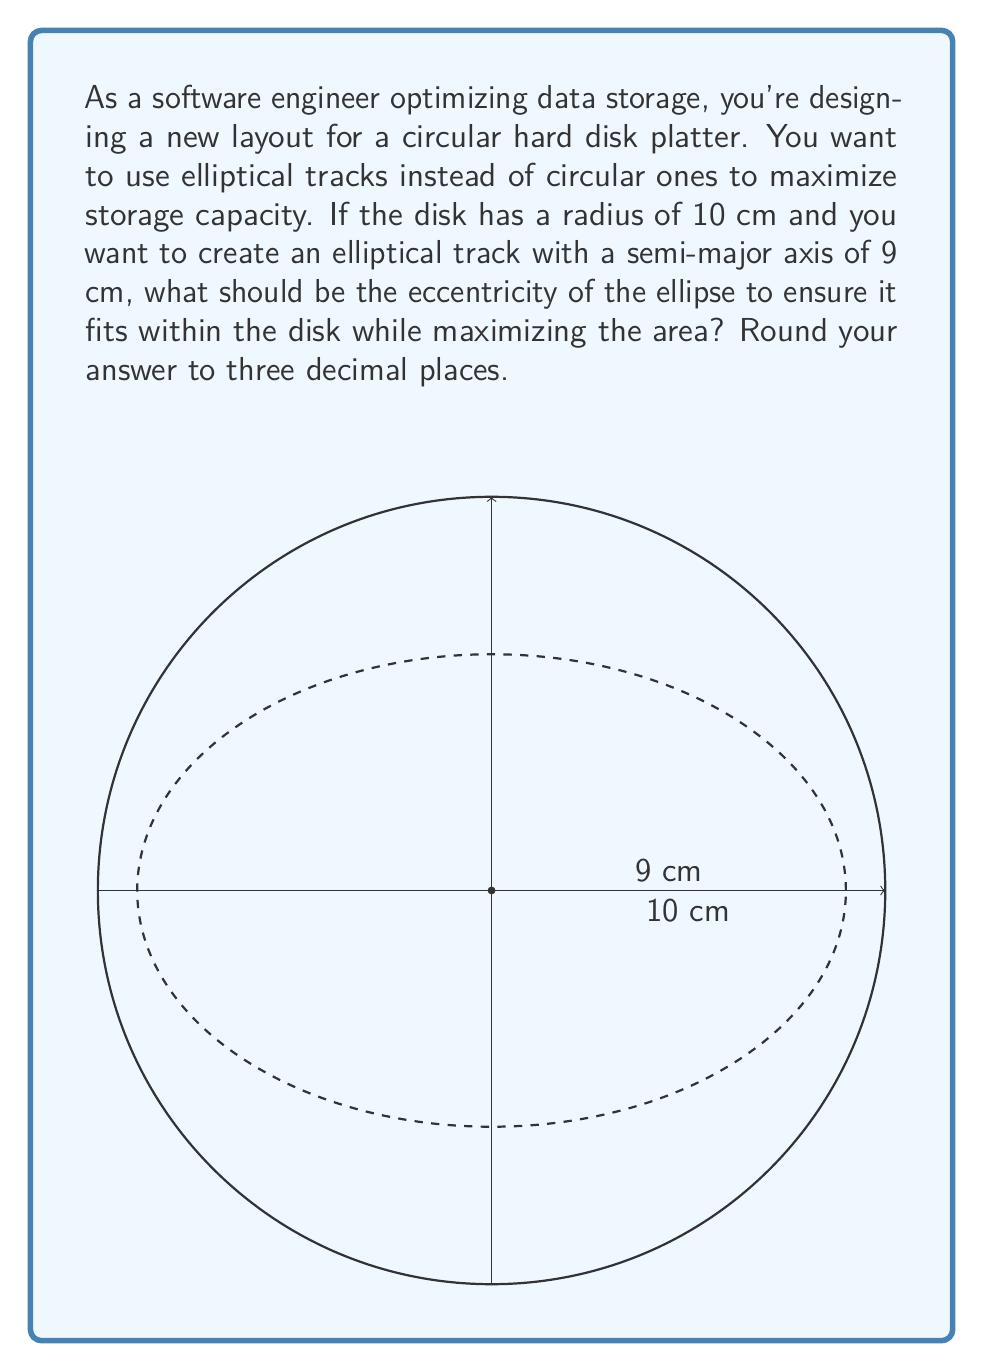Can you answer this question? Let's approach this step-by-step:

1) The equation of an ellipse with center at the origin is:

   $$\frac{x^2}{a^2} + \frac{y^2}{b^2} = 1$$

   where $a$ is the semi-major axis and $b$ is the semi-minor axis.

2) We know that $a = 9$ cm. We need to find $b$.

3) The eccentricity of an ellipse is given by:

   $$e = \sqrt{1 - \frac{b^2}{a^2}}$$

4) To maximize the area while fitting within the disk, the ellipse should touch the edge of the disk. This means that the semi-minor axis $b$ should be equal to the difference between the disk radius and the focal distance of the ellipse.

5) The focal distance $c$ is related to $a$ and $e$ by:

   $$c = ae$$

6) Therefore, $b = 10 - ae$

7) Substituting this into the eccentricity formula:

   $$e = \sqrt{1 - \frac{(10-ae)^2}{a^2}}$$

8) Substituting $a = 9$:

   $$e = \sqrt{1 - \frac{(10-9e)^2}{81}}$$

9) Expanding:

   $$e^2 = 1 - \frac{100-180e+81e^2}{81}$$

10) Simplifying:

    $$81e^2 = 81 - 100 + 180e - 81e^2$$
    $$162e^2 - 180e + 19 = 0$$

11) This is a quadratic equation. We can solve it using the quadratic formula:

    $$e = \frac{180 \pm \sqrt{180^2 - 4(162)(19)}}{2(162)}$$

12) Solving this:

    $$e \approx 0.955 \text{ or } 0.156$$

13) The larger value (0.955) gives us the maximum area while fitting within the disk.
Answer: $e \approx 0.955$ 